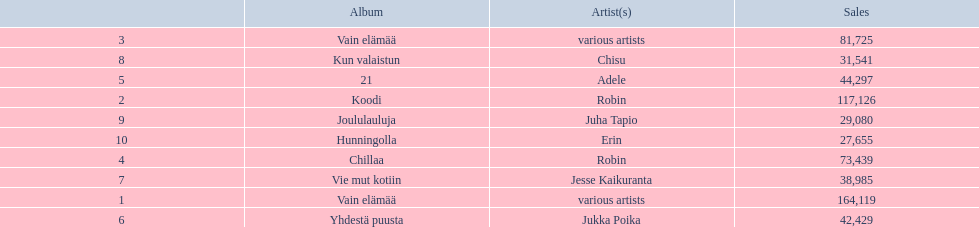Which artists' albums reached number one in finland during 2012? 164,119, 117,126, 81,725, 73,439, 44,297, 42,429, 38,985, 31,541, 29,080, 27,655. What were the sales figures of these albums? Various artists, robin, various artists, robin, adele, jukka poika, jesse kaikuranta, chisu, juha tapio, erin. And did adele or chisu have more sales during this period? Adele. 